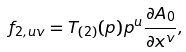<formula> <loc_0><loc_0><loc_500><loc_500>f _ { 2 , u v } = T _ { ( 2 ) } ( p ) p ^ { u } \frac { \partial A _ { 0 } } { \partial x ^ { v } } ,</formula> 